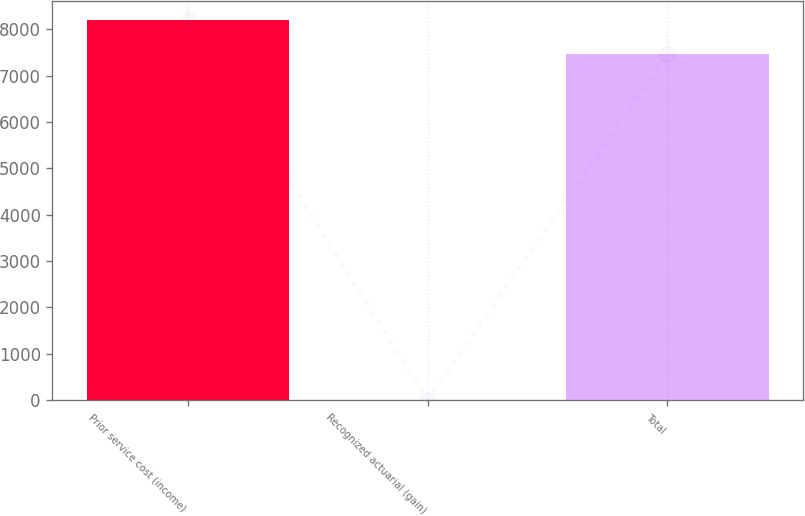<chart> <loc_0><loc_0><loc_500><loc_500><bar_chart><fcel>Prior service cost (income)<fcel>Recognized actuarial (gain)<fcel>Total<nl><fcel>8208.2<fcel>1<fcel>7462<nl></chart> 